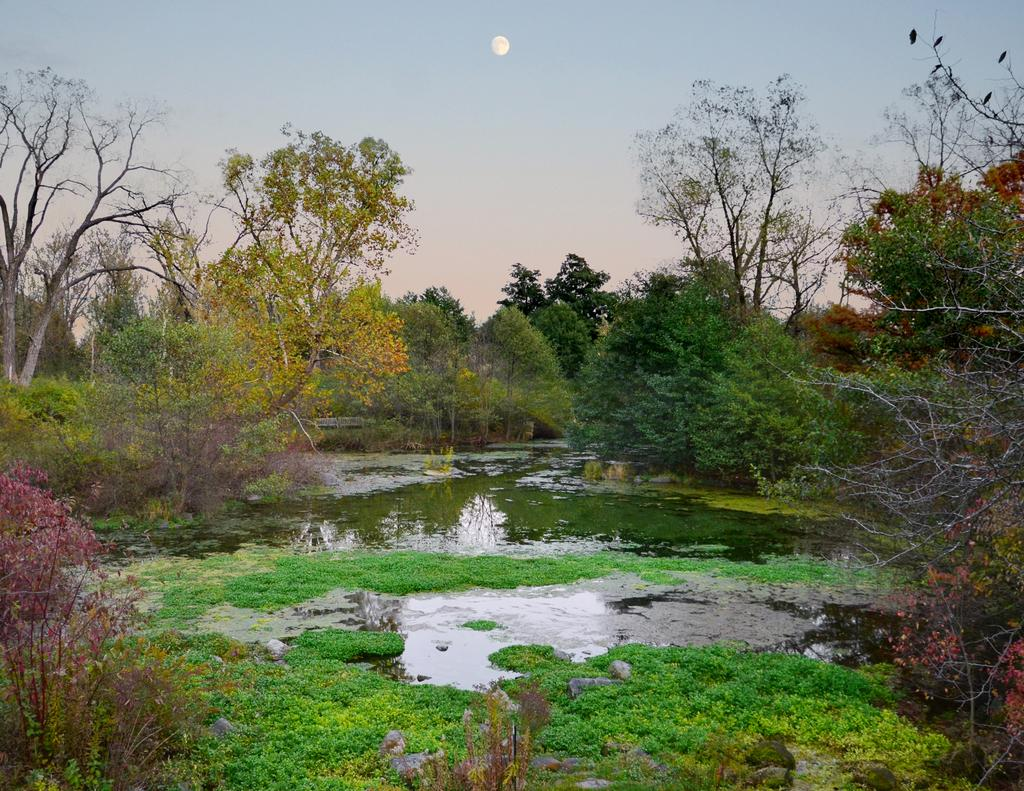What is the main feature in the center of the image? There is water in the center of the image. What is unusual about the water in the image? There is grass on the surface of the water. What type of vegetation can be seen in the image? There are trees in the image. What celestial body is visible in the sky at the top of the image? The moon is visible in the sky at the top of the image. What type of glove is being used to manipulate the memory in the image? There is no glove or memory manipulation present in the image. 